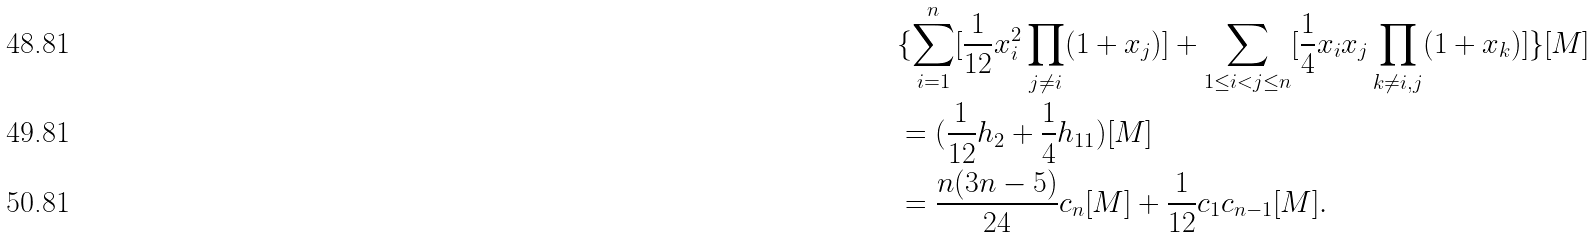Convert formula to latex. <formula><loc_0><loc_0><loc_500><loc_500>& \{ \sum _ { i = 1 } ^ { n } [ \frac { 1 } { 1 2 } x _ { i } ^ { 2 } \prod _ { j \neq i } ( 1 + x _ { j } ) ] + \sum _ { 1 \leq i < j \leq n } [ \frac { 1 } { 4 } x _ { i } x _ { j } \prod _ { k \neq i , j } ( 1 + x _ { k } ) ] \} [ M ] \\ & = ( \frac { 1 } { 1 2 } h _ { 2 } + \frac { 1 } { 4 } h _ { 1 1 } ) [ M ] \\ & = \frac { n ( 3 n - 5 ) } { 2 4 } c _ { n } [ M ] + \frac { 1 } { 1 2 } c _ { 1 } c _ { n - 1 } [ M ] .</formula> 